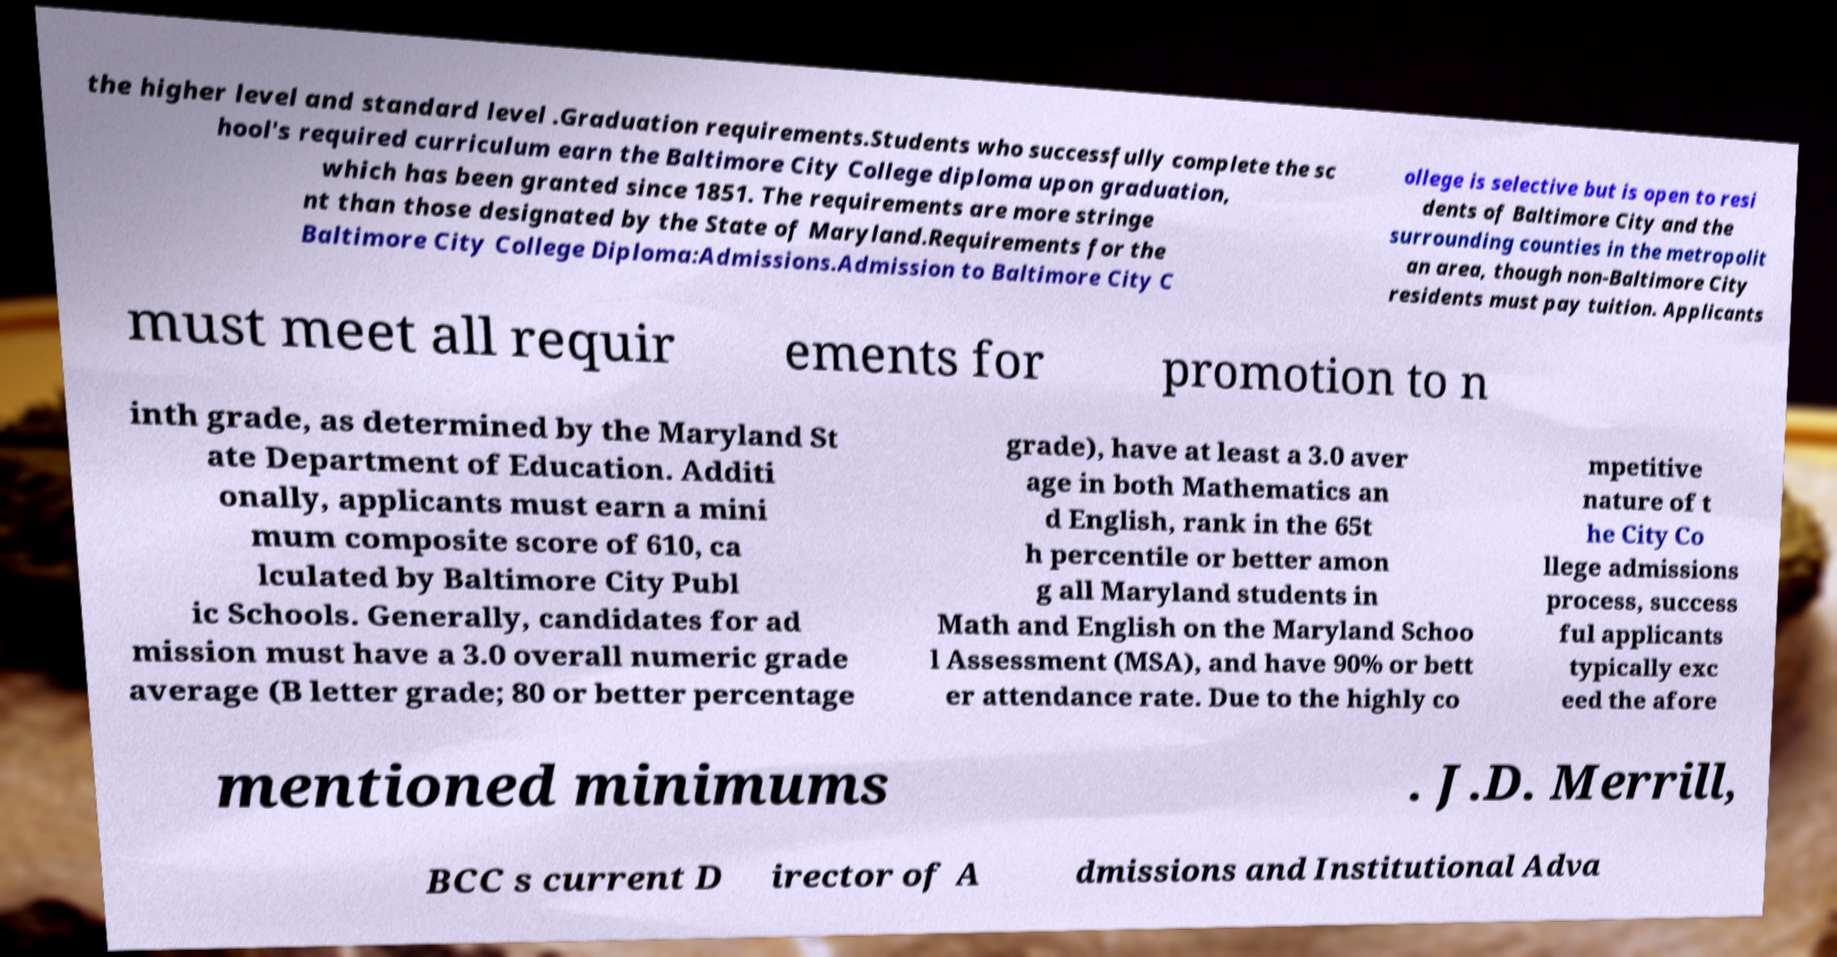Could you assist in decoding the text presented in this image and type it out clearly? the higher level and standard level .Graduation requirements.Students who successfully complete the sc hool's required curriculum earn the Baltimore City College diploma upon graduation, which has been granted since 1851. The requirements are more stringe nt than those designated by the State of Maryland.Requirements for the Baltimore City College Diploma:Admissions.Admission to Baltimore City C ollege is selective but is open to resi dents of Baltimore City and the surrounding counties in the metropolit an area, though non-Baltimore City residents must pay tuition. Applicants must meet all requir ements for promotion to n inth grade, as determined by the Maryland St ate Department of Education. Additi onally, applicants must earn a mini mum composite score of 610, ca lculated by Baltimore City Publ ic Schools. Generally, candidates for ad mission must have a 3.0 overall numeric grade average (B letter grade; 80 or better percentage grade), have at least a 3.0 aver age in both Mathematics an d English, rank in the 65t h percentile or better amon g all Maryland students in Math and English on the Maryland Schoo l Assessment (MSA), and have 90% or bett er attendance rate. Due to the highly co mpetitive nature of t he City Co llege admissions process, success ful applicants typically exc eed the afore mentioned minimums . J.D. Merrill, BCC s current D irector of A dmissions and Institutional Adva 